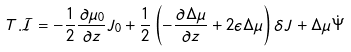Convert formula to latex. <formula><loc_0><loc_0><loc_500><loc_500>T . \mathcal { I } = - \frac { 1 } { 2 } \frac { \partial \mu _ { 0 } } { \partial z } J _ { 0 } + \frac { 1 } { 2 } \left ( - \frac { \partial \Delta \mu } { \partial z } + 2 \epsilon \Delta \mu \right ) \delta J + \Delta \mu \dot { \Psi }</formula> 